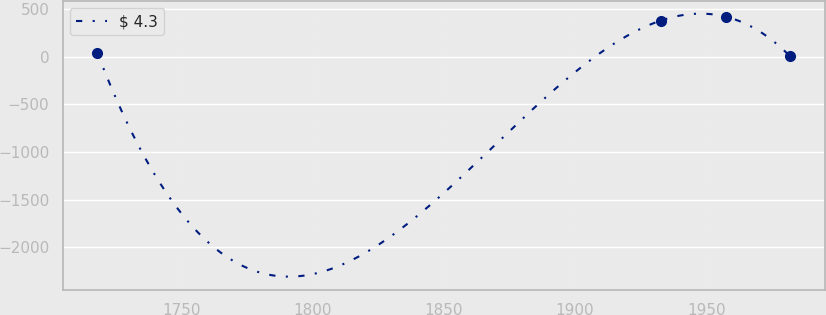<chart> <loc_0><loc_0><loc_500><loc_500><line_chart><ecel><fcel>$ 4.3<nl><fcel>1718.01<fcel>42.93<nl><fcel>1932.57<fcel>377.48<nl><fcel>1957.57<fcel>417.73<nl><fcel>1981.96<fcel>2.68<nl></chart> 